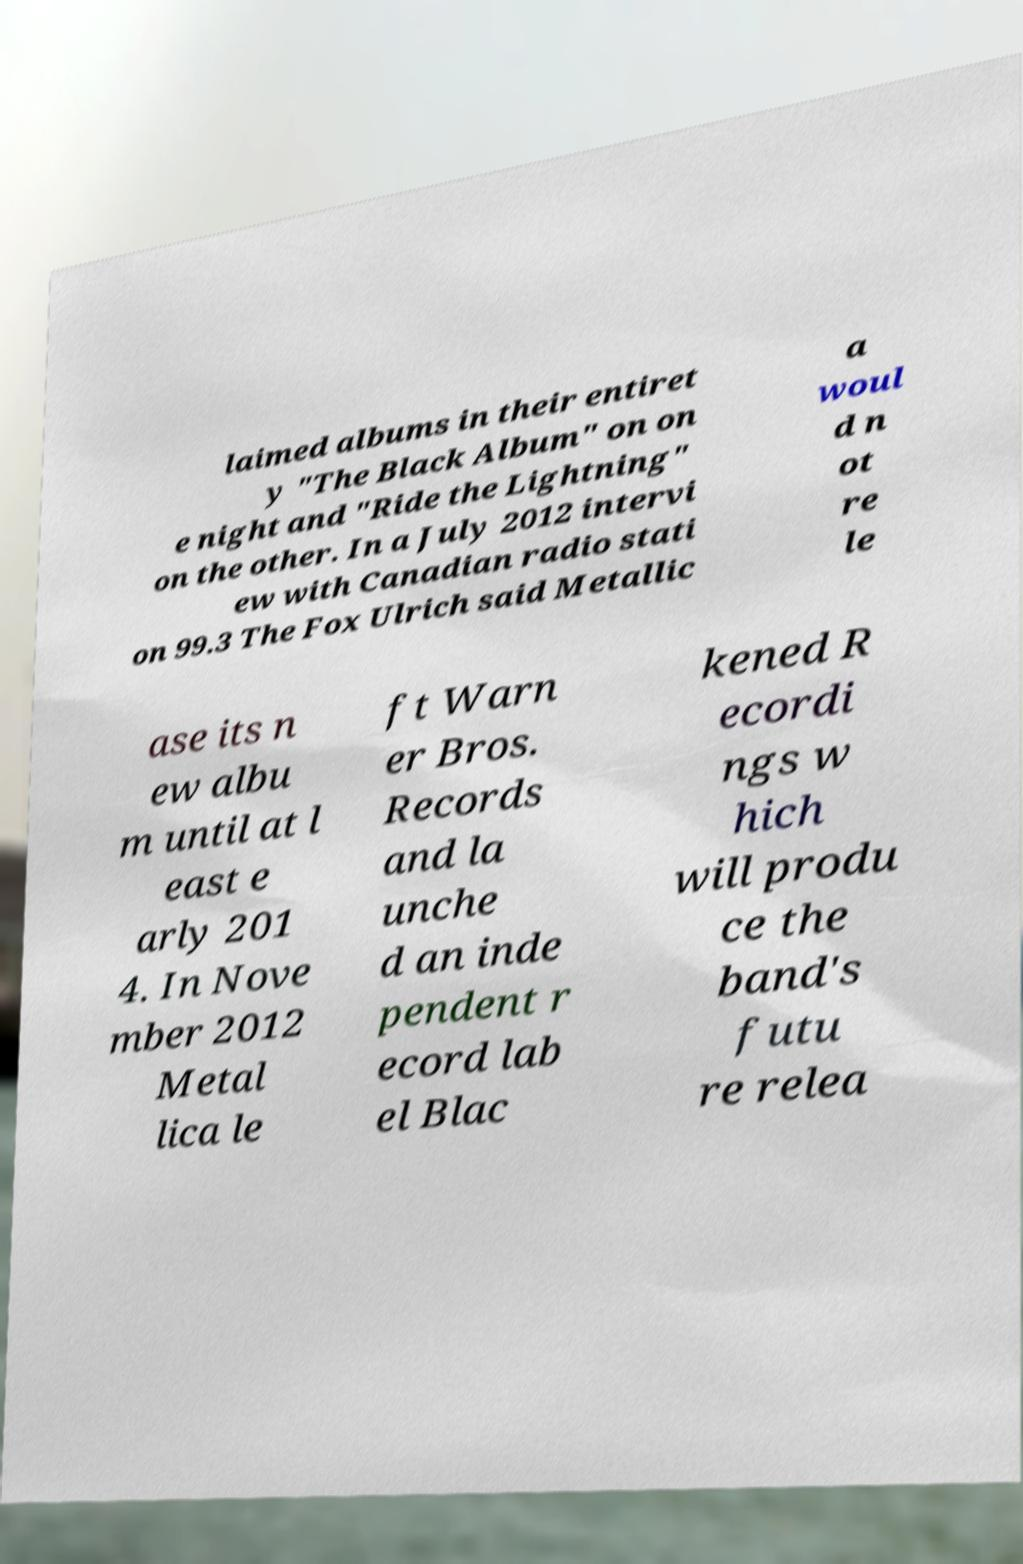Can you accurately transcribe the text from the provided image for me? laimed albums in their entiret y "The Black Album" on on e night and "Ride the Lightning" on the other. In a July 2012 intervi ew with Canadian radio stati on 99.3 The Fox Ulrich said Metallic a woul d n ot re le ase its n ew albu m until at l east e arly 201 4. In Nove mber 2012 Metal lica le ft Warn er Bros. Records and la unche d an inde pendent r ecord lab el Blac kened R ecordi ngs w hich will produ ce the band's futu re relea 